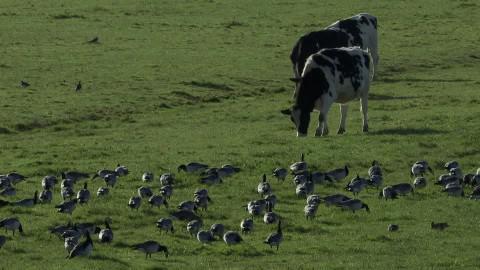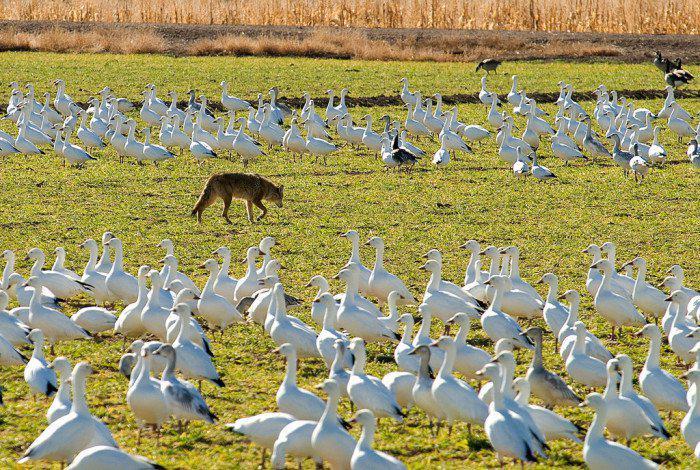The first image is the image on the left, the second image is the image on the right. Given the left and right images, does the statement "One of the images shows at least one cow standing in a field behind a flock of geese." hold true? Answer yes or no. Yes. The first image is the image on the left, the second image is the image on the right. For the images shown, is this caption "An image includes at least one cow standing behind a flock of birds in a field." true? Answer yes or no. Yes. 